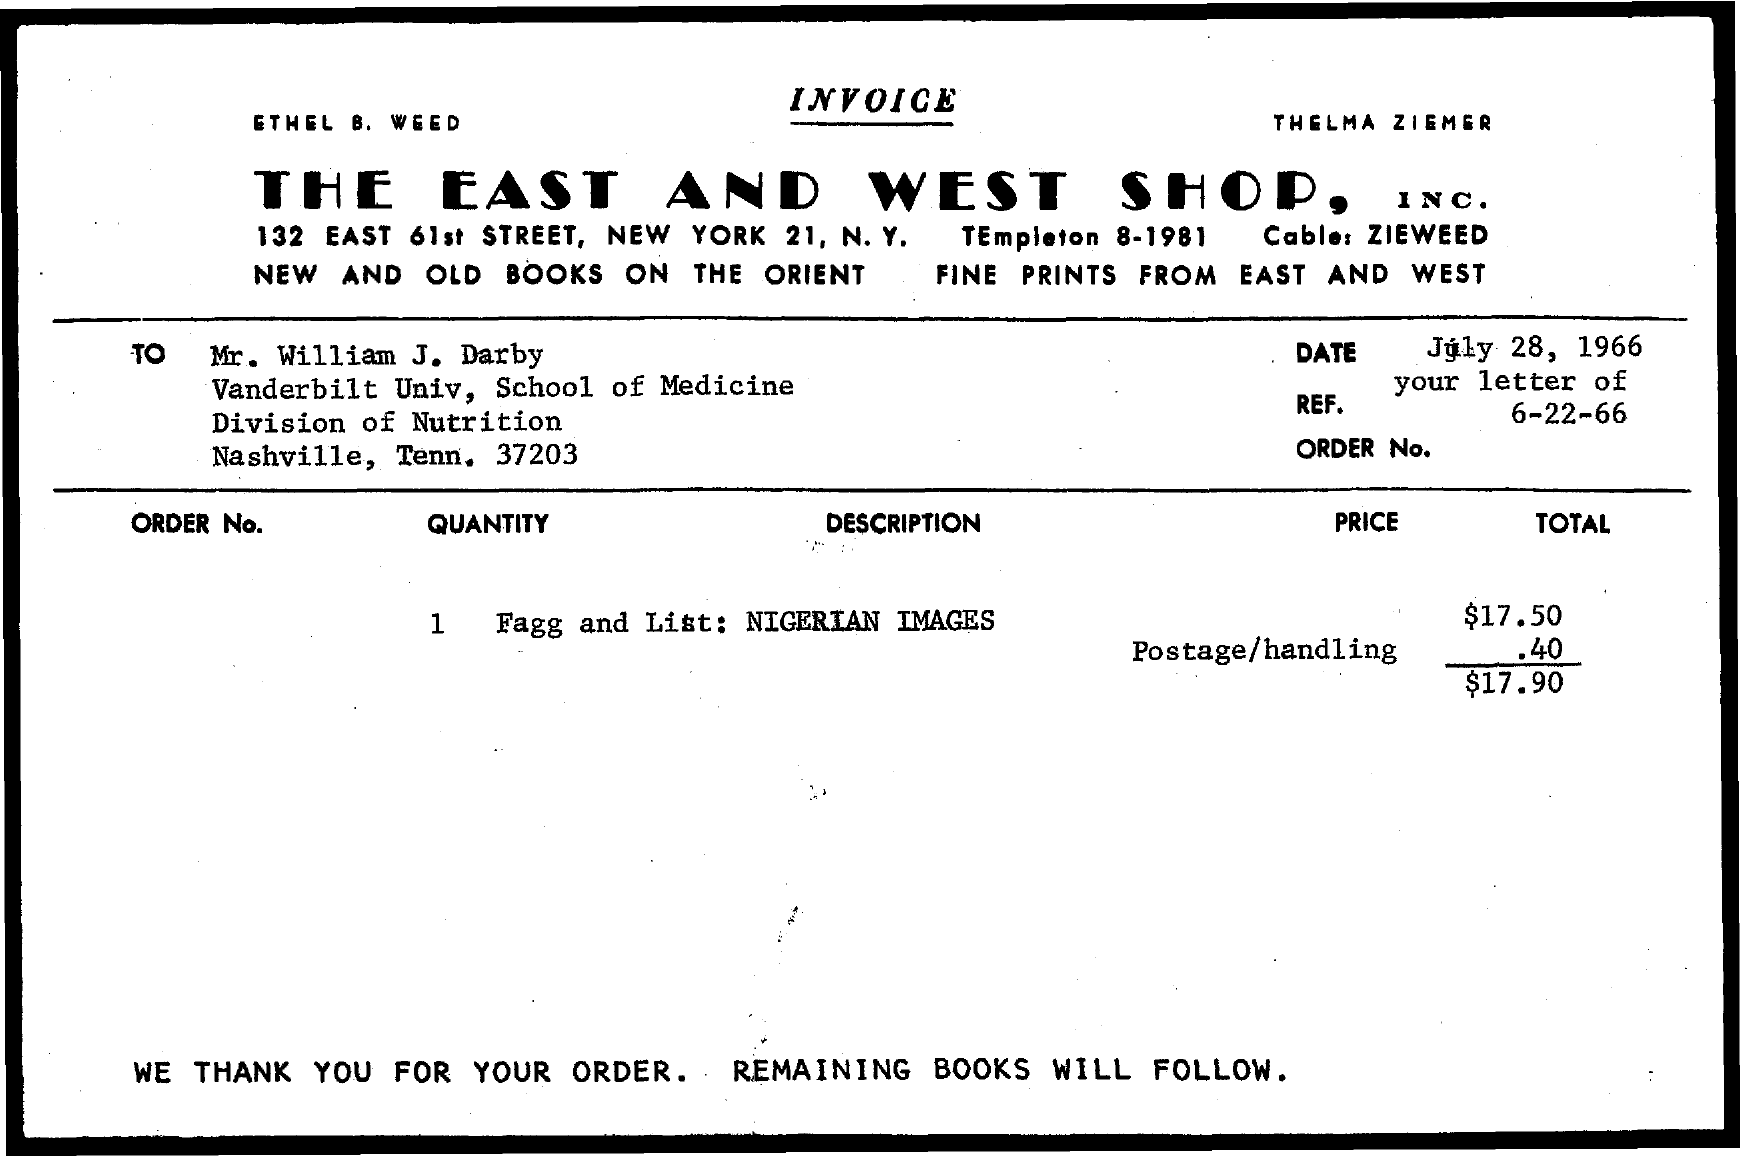Which company is raising the invoice?
Keep it short and to the point. THE EAST AND WEST SHOP, INC. What is the payee's name given in the invoice?
Your answer should be compact. Mr. William J. Darby. What is the description of the quantity mentioned in the invoice?
Provide a succinct answer. Fagg and List: NIGERIAN IMAGES. What is the total invoice amount given?
Provide a succinct answer. $17.90. 